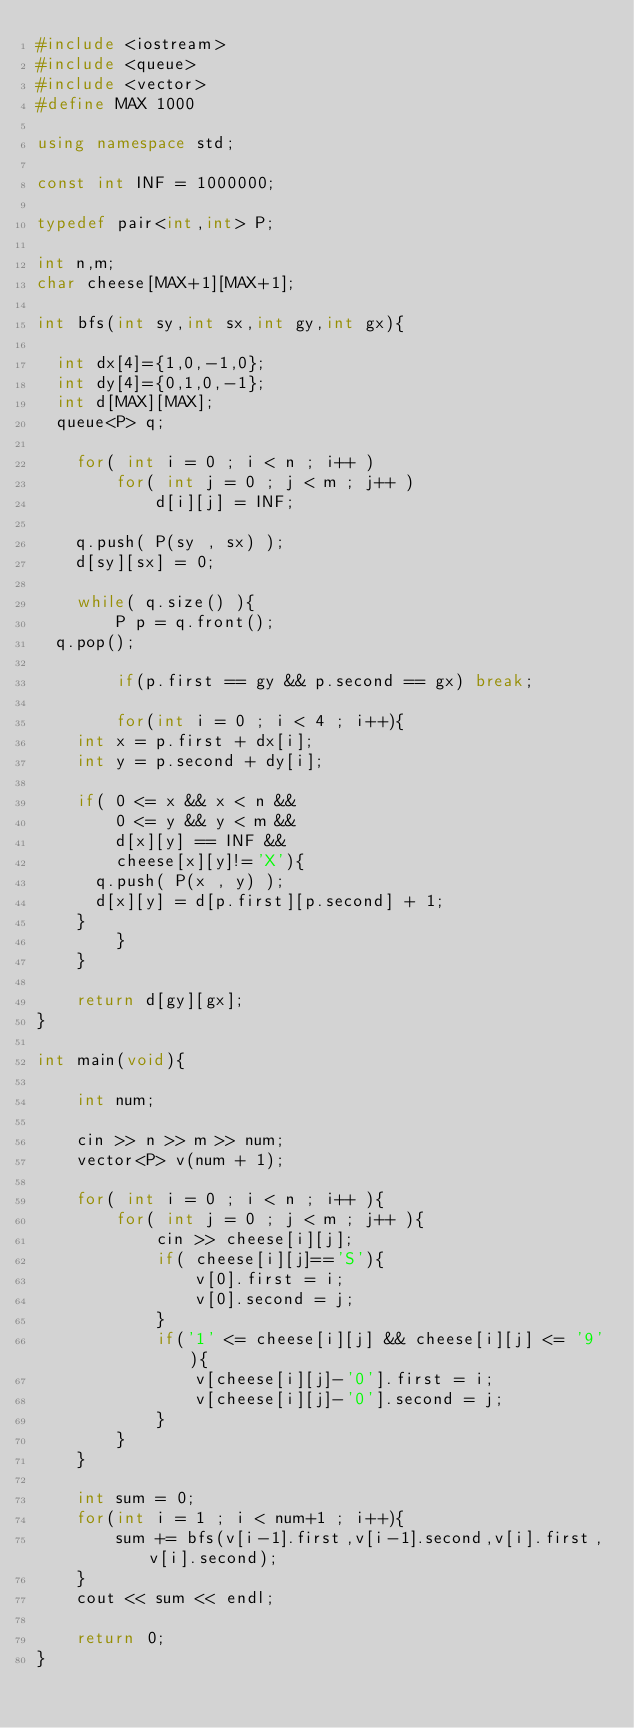<code> <loc_0><loc_0><loc_500><loc_500><_C++_>#include <iostream>
#include <queue>
#include <vector>
#define MAX 1000

using namespace std;

const int INF = 1000000;

typedef pair<int,int> P;

int n,m;
char cheese[MAX+1][MAX+1];
 
int bfs(int sy,int sx,int gy,int gx){
    
  int dx[4]={1,0,-1,0};
  int dy[4]={0,1,0,-1};
  int d[MAX][MAX];
  queue<P> q;
     
    for( int i = 0 ; i < n ; i++ )
        for( int j = 0 ; j < m ; j++ )
            d[i][j] = INF;
     
    q.push( P(sy , sx) );
    d[sy][sx] = 0;
     
    while( q.size() ){
        P p = q.front(); 
	q.pop();

        if(p.first == gy && p.second == gx) break;
	
        for(int i = 0 ; i < 4 ; i++){
	  int x = p.first + dx[i];
	  int y = p.second + dy[i];
          
	  if( 0 <= x && x < n &&
	      0 <= y && y < m &&
	      d[x][y] == INF &&
	      cheese[x][y]!='X'){
	    q.push( P(x , y) );
	    d[x][y] = d[p.first][p.second] + 1;
	  }
        }
    }
    
    return d[gy][gx];
}

int main(void){

    int num;
 
    cin >> n >> m >> num;
    vector<P> v(num + 1);
     
    for( int i = 0 ; i < n ; i++ ){
        for( int j = 0 ; j < m ; j++ ){
            cin >> cheese[i][j];
            if( cheese[i][j]=='S'){
                v[0].first = i;
                v[0].second = j;
            }
            if('1' <= cheese[i][j] && cheese[i][j] <= '9'){
                v[cheese[i][j]-'0'].first = i;
                v[cheese[i][j]-'0'].second = j;
            }
        }
    }
     
    int sum = 0;
    for(int i = 1 ; i < num+1 ; i++){
        sum += bfs(v[i-1].first,v[i-1].second,v[i].first,v[i].second);
    }
    cout << sum << endl;
     
    return 0;
}</code> 